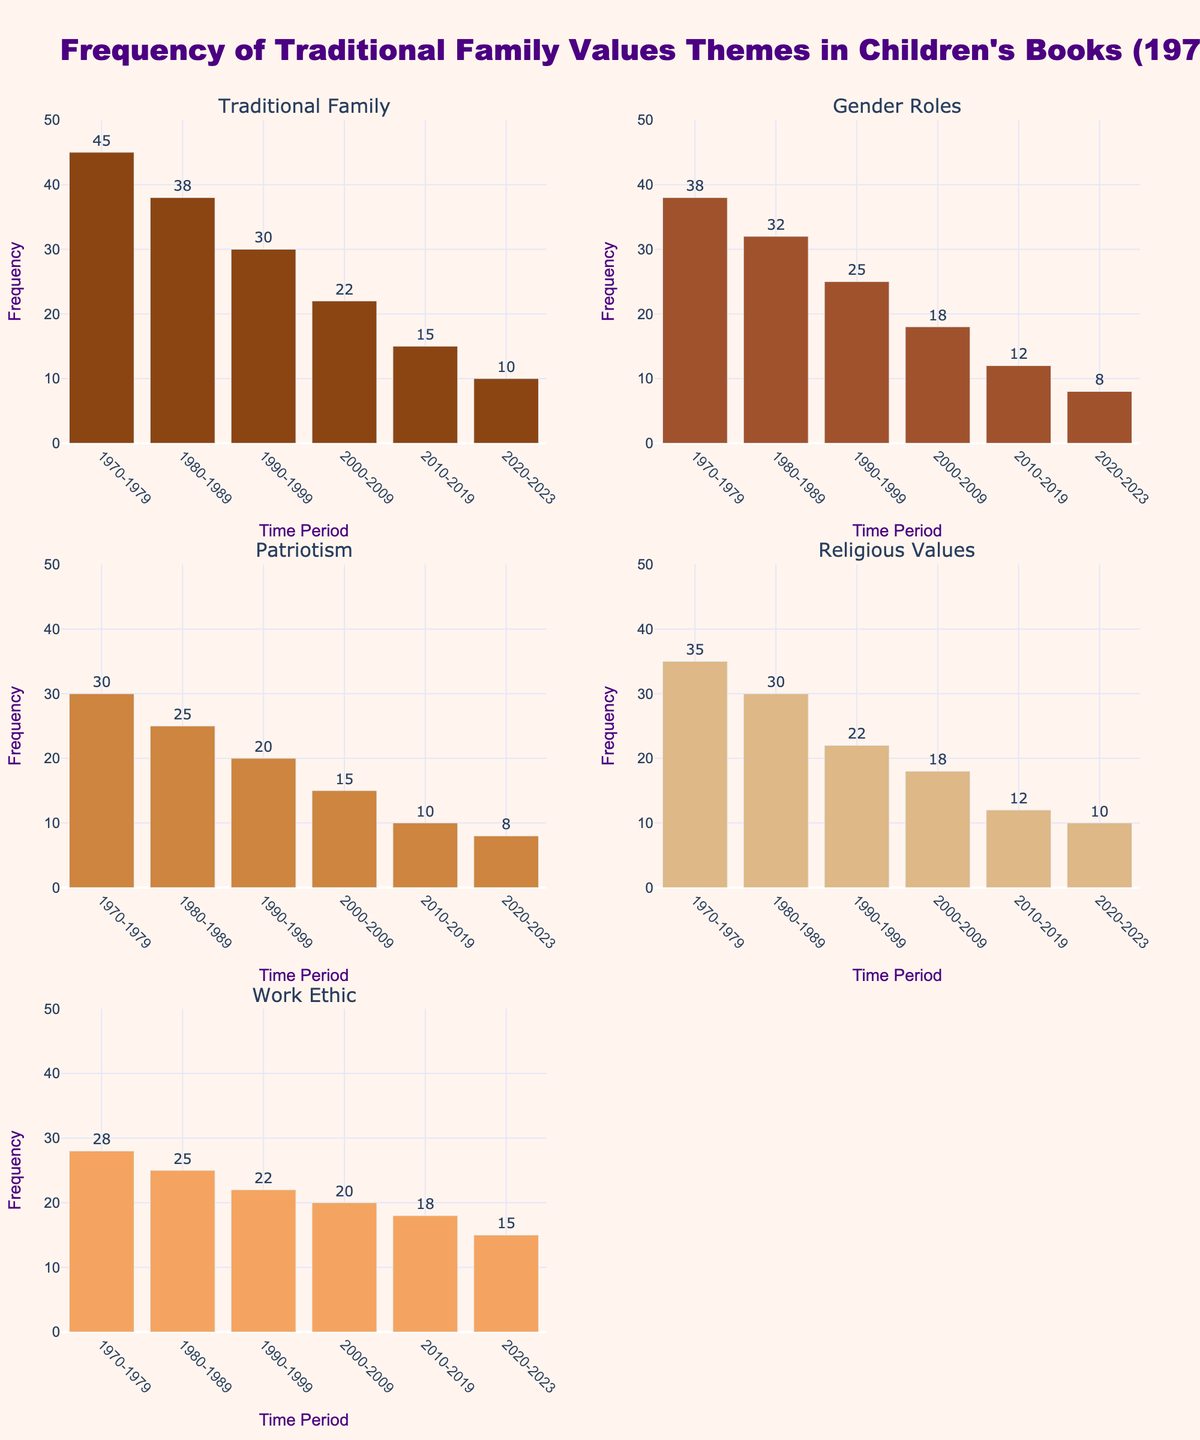What is the highest frequency of the "Traditional Family" theme in the given years? Look at the subplot for the "Traditional Family" theme and identify the bar with the highest value.
Answer: 45 In which time period did the "Patriotism" theme drop to its lowest frequency? Check the subplot for the "Patriotism" theme and find the bar with the lowest height.
Answer: 2010-2019 How many themes have a frequency of 8 in the period 2020-2023? Count the bars in the year 2020-2023 across all subplots that have a height of 8 units.
Answer: 2 What can you observe about the trend in the frequency of the "Religious Values" theme over the past 50 years? Analyze the bars in the subplot for "Religious Values" and describe the trend from the earliest to the latest time period.
Answer: The trend is decreasing Which theme shows the most consistent decrease over the given time periods? Compare the subplots and identify the theme whose bars decrease steadily in height across all the given time periods.
Answer: Traditional Family By how much did the frequency of the "Work Ethic" theme decrease from 1970-1979 to 2020-2023? Subtract the height of the bar in 2020-2023 from the height of the bar in 1970-1979 in the "Work Ethic" subplot.
Answer: 13 Compare the initial frequency of "Gender Roles" to its frequency in 2020-2023. How does the latter measure up to the former? Look at the heights of the bars in the "Gender Roles" subplot for 1970-1979 and 2020-2023, then compare.
Answer: Much lower Which time period shows the greatest reduction in the "Traditional Family" theme frequency compared to the previous period? Calculate the differences in bar heights for "Traditional Family" between consecutive periods and identify the largest drop.
Answer: 1990-1999 compared to 1980-1989 How does the frequency of "Work Ethic" in 2000-2009 compare to that in 1970-1979? Compare the height of the bars for "Work Ethic" in the respective periods.
Answer: Lower Is there any time period where the frequency of "Gender Roles" is equal to that of "Patriotism"? If yes, specify the period. Check all subplots for instances where the bars for "Gender Roles" and "Patriotism" have the same height in the same time period.
Answer: 2020-2023 